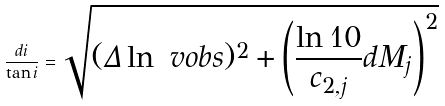<formula> <loc_0><loc_0><loc_500><loc_500>\frac { d i } { \tan i } = \sqrt { ( \Delta \ln \ v o b s ) ^ { 2 } + \left ( \frac { \ln 1 0 } { c _ { 2 , j } } d M _ { j } \right ) ^ { 2 } }</formula> 